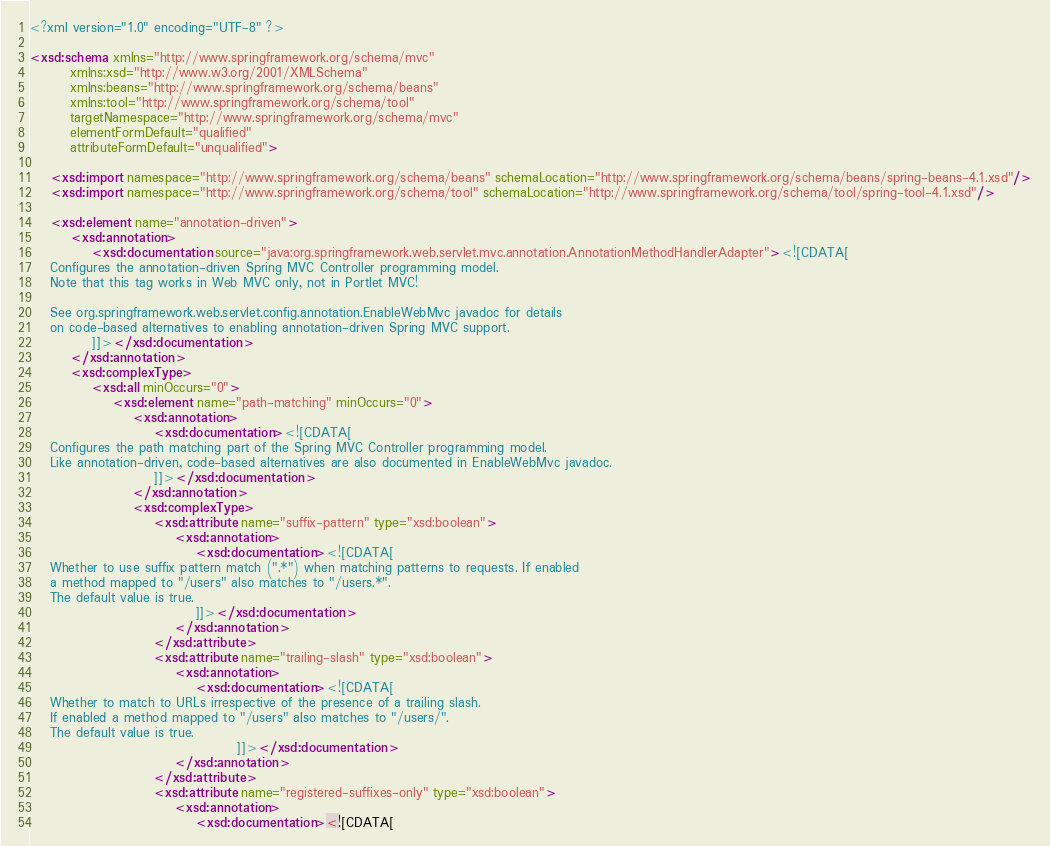Convert code to text. <code><loc_0><loc_0><loc_500><loc_500><_XML_><?xml version="1.0" encoding="UTF-8" ?>

<xsd:schema xmlns="http://www.springframework.org/schema/mvc"
		xmlns:xsd="http://www.w3.org/2001/XMLSchema"
		xmlns:beans="http://www.springframework.org/schema/beans"
		xmlns:tool="http://www.springframework.org/schema/tool"
		targetNamespace="http://www.springframework.org/schema/mvc"
		elementFormDefault="qualified"
		attributeFormDefault="unqualified">

	<xsd:import namespace="http://www.springframework.org/schema/beans" schemaLocation="http://www.springframework.org/schema/beans/spring-beans-4.1.xsd"/>
	<xsd:import namespace="http://www.springframework.org/schema/tool" schemaLocation="http://www.springframework.org/schema/tool/spring-tool-4.1.xsd"/>

	<xsd:element name="annotation-driven">
		<xsd:annotation>
			<xsd:documentation source="java:org.springframework.web.servlet.mvc.annotation.AnnotationMethodHandlerAdapter"><![CDATA[
	Configures the annotation-driven Spring MVC Controller programming model.
	Note that this tag works in Web MVC only, not in Portlet MVC!

	See org.springframework.web.servlet.config.annotation.EnableWebMvc javadoc for details
	on code-based alternatives to enabling annotation-driven Spring MVC support.
			]]></xsd:documentation>
		</xsd:annotation>
		<xsd:complexType>
			<xsd:all minOccurs="0">
				<xsd:element name="path-matching" minOccurs="0">
					<xsd:annotation>
						<xsd:documentation><![CDATA[
	Configures the path matching part of the Spring MVC Controller programming model.
	Like annotation-driven, code-based alternatives are also documented in EnableWebMvc javadoc.
						]]></xsd:documentation>
					</xsd:annotation>
					<xsd:complexType>
						<xsd:attribute name="suffix-pattern" type="xsd:boolean">
							<xsd:annotation>
								<xsd:documentation><![CDATA[
	Whether to use suffix pattern match (".*") when matching patterns to requests. If enabled
	a method mapped to "/users" also matches to "/users.*".
	The default value is true.
								]]></xsd:documentation>
							</xsd:annotation>
						</xsd:attribute>
						<xsd:attribute name="trailing-slash" type="xsd:boolean">
							<xsd:annotation>
								<xsd:documentation><![CDATA[
	Whether to match to URLs irrespective of the presence of a trailing slash.
	If enabled a method mapped to "/users" also matches to "/users/".
	The default value is true.
										]]></xsd:documentation>
							</xsd:annotation>
						</xsd:attribute>
						<xsd:attribute name="registered-suffixes-only" type="xsd:boolean">
							<xsd:annotation>
								<xsd:documentation><![CDATA[</code> 